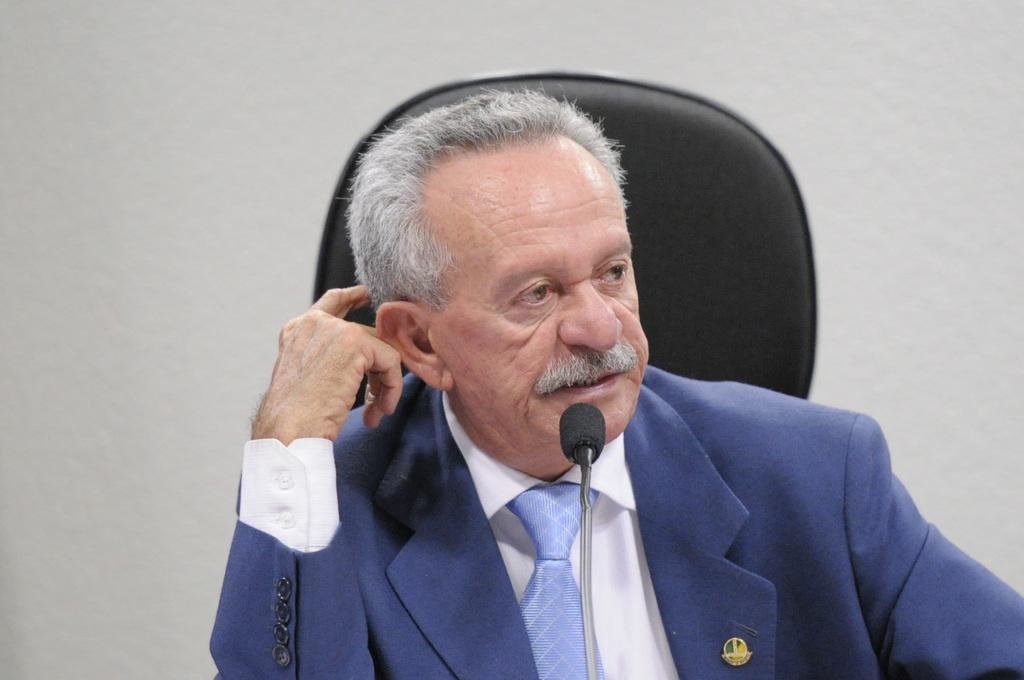Who is the main subject in the image? There is an old man in the image. What is the old man wearing? The old man is wearing a suit. What is the old man doing in the image? The old man is sitting on a chair and talking in front of a microphone. What can be seen in the background of the image? There is a white wall in the background of the image. What type of marble is present on the floor in the image? There is no marble present on the floor in the image. What is the old man trying to prevent in the image? The image does not provide information about the old man trying to prevent anything, as he is talking in front of a microphone. 